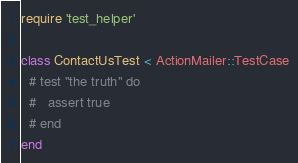Convert code to text. <code><loc_0><loc_0><loc_500><loc_500><_Ruby_>require 'test_helper'

class ContactUsTest < ActionMailer::TestCase
  # test "the truth" do
  #   assert true
  # end
end
</code> 